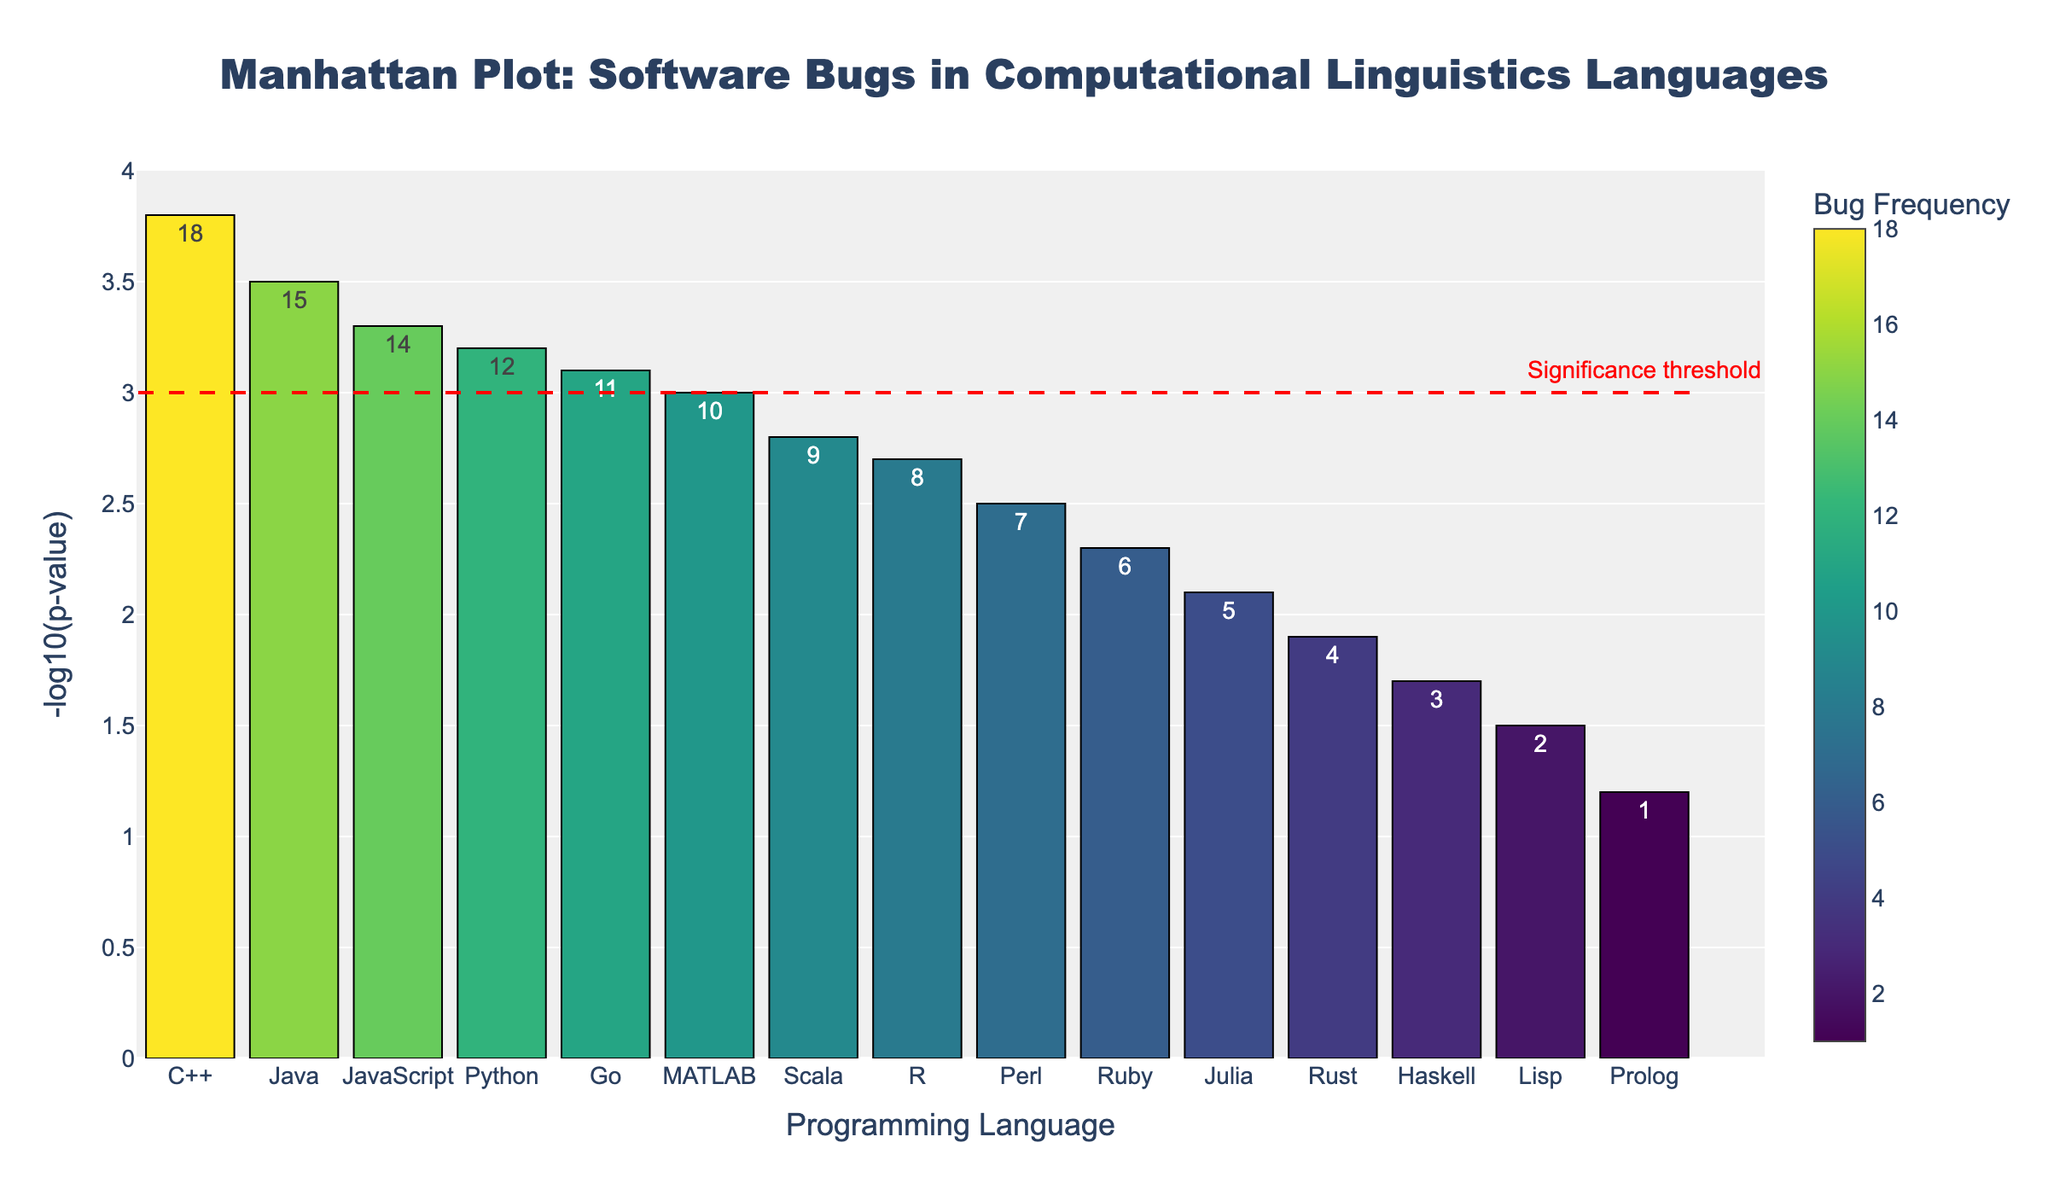What does the y-axis represent? The y-axis represents the negative logarithm base 10 of the p-value, which is a measure of statistical significance of the bug frequency in each language. The higher the value, the more statistically significant the bug frequency is.
Answer: -log10(p-value) Which programming language has the highest -log10(p-value)? By looking at the bar heights on the y-axis, C++ has the highest -log10(p-value) reaching up to 3.8.
Answer: C++ What is the minimum bug frequency shown in the plot and which language does it correspond to? The smallest number in the "Bug_Frequency" category is 1, which corresponds to the language Prolog as indicated by the color scale showing low values.
Answer: Prolog How many languages have a -log10(p-value) above the significance threshold (y = 3)? To determine this, count the bars that extend above the red dashed significance line at y = 3. Python, Java, C++, JavaScript, and Go are above the threshold.
Answer: 5 Which language has a bug frequency of 12 and what is its corresponding -log10(p-value)? By checking the hover information or text labels on the bars, Python has a bug frequency of 12, and its corresponding -log10(p-value) is 3.2.
Answer: Python, 3.2 Which language has the lowest -log10(p-value), and what is its bug frequency? The lowest -log10(p-value) bar is for Prolog, which has a -log10(p-value) of 1.2. Its bug frequency is displayed as 1.
Answer: Prolog, 1 What is the difference in -log10(p-value) between the programming languages Go and Rust? By referring to the y-axis values of Go and Rust: Go has a -log10(p-value) of 3.1 and Rust has 1.9. The difference is 3.1 - 1.9 = 1.2.
Answer: 1.2 Among Python, JavaScript, and Julia, which has the highest bug frequency and how do their -log10(p-value) values compare? Python has the highest bug frequency of 12. Comparing their -log10(p-value) values: Python (3.2), JavaScript (3.3), and Julia (2.1), JavaScript has the highest -log10(p-value) among them.
Answer: Python, JavaScript By how much does the -log10(p-value) of Java exceed that of MATLAB? Java has a -log10(p-value) of 3.5, and MATLAB has 3.0. The difference is 3.5 - 3.0 = 0.5.
Answer: 0.5 Which programming language has the bug frequency closest to the median bug frequency of all the listed languages, and what is the median -log10(p-value)? The bug frequencies in ascending order are: 1, 2, 3, 4, 5, 6, 7, 8, 9, 10, 11, 12, 14, 15, 18. The median is the 8th value, which is 8 (corresponding to R). R has a -log10(p-value) of 2.7.
Answer: R, 2.7 